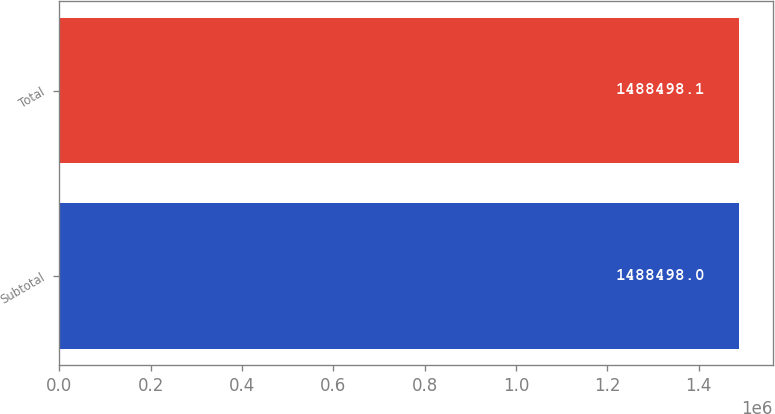<chart> <loc_0><loc_0><loc_500><loc_500><bar_chart><fcel>Subtotal<fcel>Total<nl><fcel>1.4885e+06<fcel>1.4885e+06<nl></chart> 